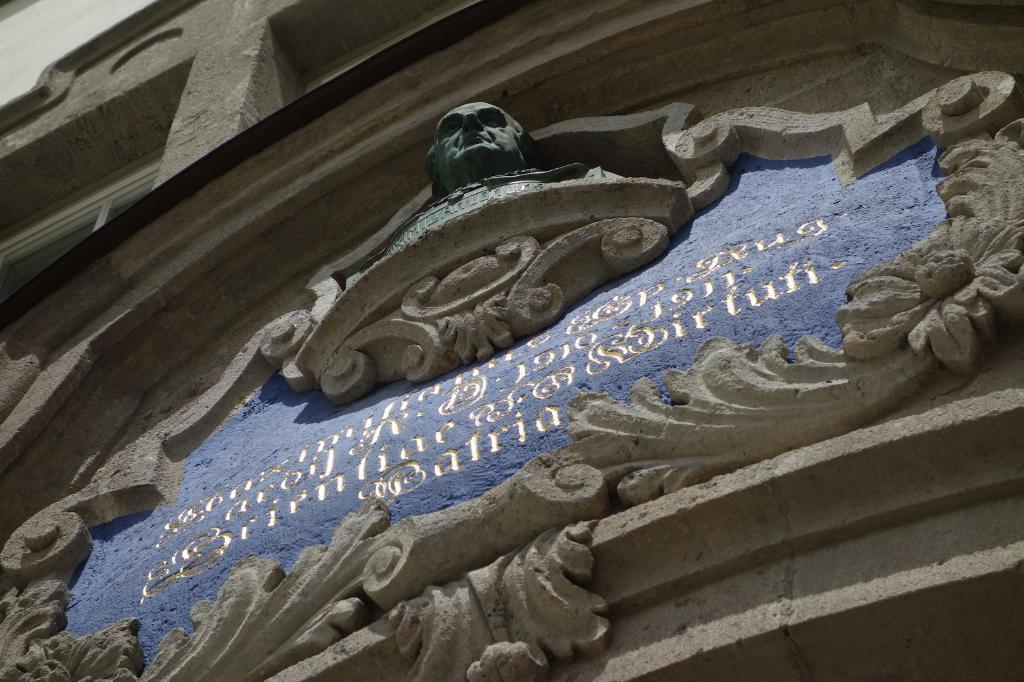What type of structure is partially visible in the image? There is a part of a building in the image. What can be seen on the wall of the building? There is text on the wall of the building. What type of artwork is present in the image? There is a sculpture of a person in the image. How much was the payment for the sculpture in the image? There is no information about payment for the sculpture in the image. 